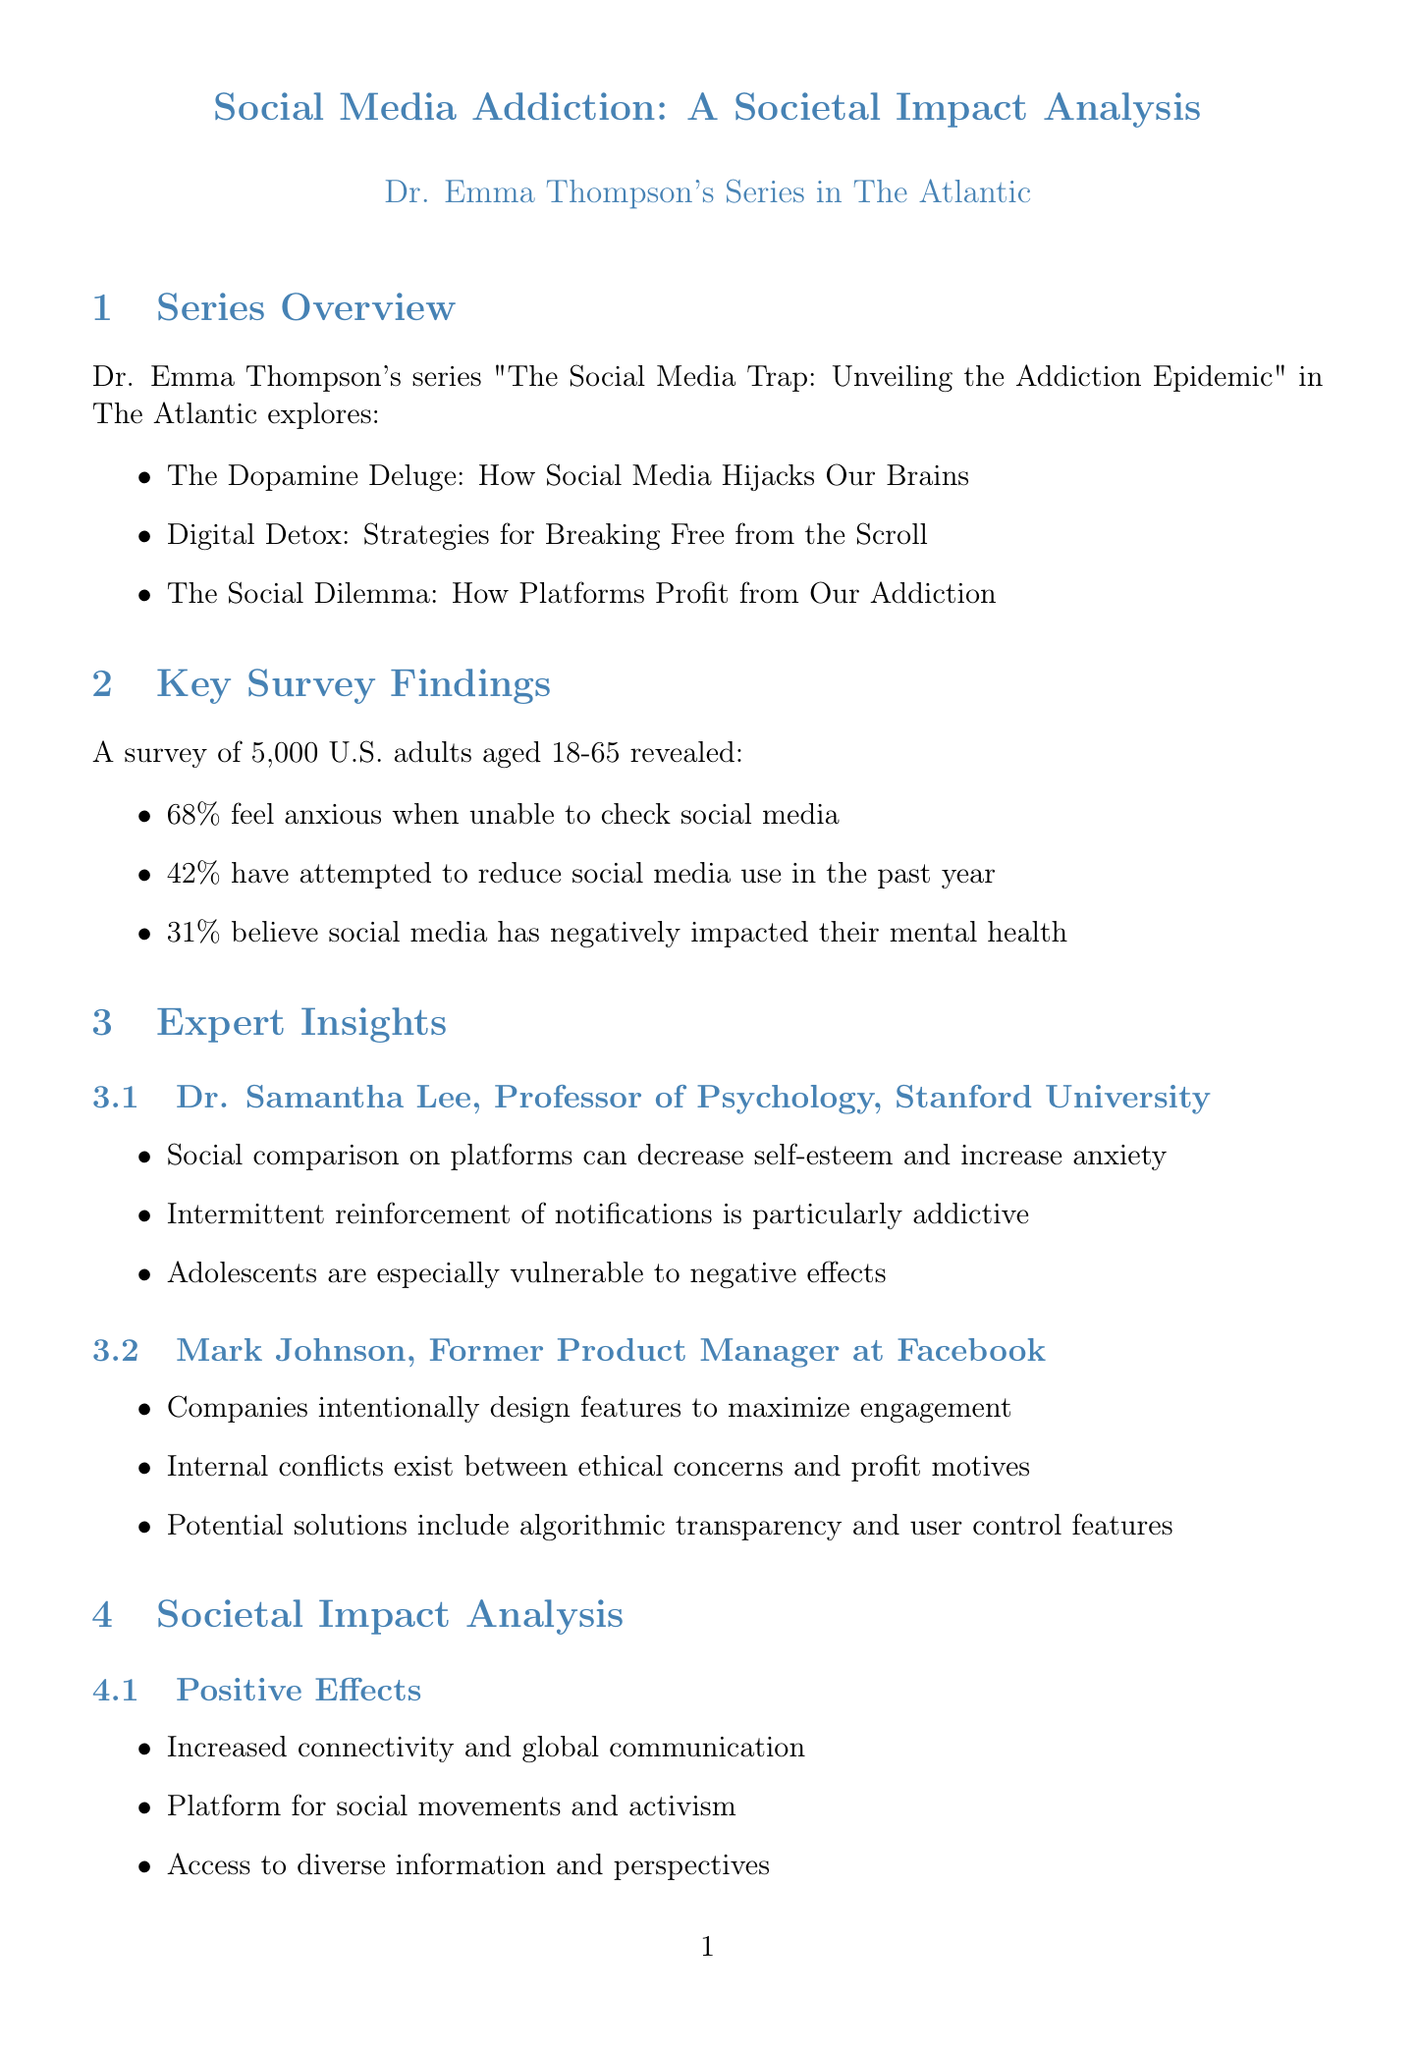What is the name of the columnist? The document mentions Dr. Emma Thompson as the columnist.
Answer: Dr. Emma Thompson What is the title of the series? The title of the series is provided in the document as "The Social Media Trap: Unveiling the Addiction Epidemic."
Answer: The Social Media Trap: Unveiling the Addiction Epidemic How many adults participated in the survey? The document states that the survey included 5,000 U.S. adults aged 18-65.
Answer: 5000 What percentage of respondents feels anxious without checking social media? The survey results indicate that 68% of respondents report anxiety when not checking social media.
Answer: 68% Who is the expert from Stanford University? The document lists Dr. Samantha Lee as the expert from Stanford University.
Answer: Dr. Samantha Lee What is one of the positive effects of social media mentioned? A positive effect listed in the document is increased connectivity and global communication.
Answer: Increased connectivity and global communication Which company did Mark Johnson formerly work for? The document indicates that Mark Johnson was a former product manager at Facebook.
Answer: Facebook What is one recommendation for future research? The document includes a recommendation for longitudinal studies on the developmental impacts of social media use.
Answer: Longitudinal studies on developmental impacts of social media use What is the implication of 31% of respondents believing social media has negatively affected their mental health? The document states that this indicates a significant perceived psychological toll of excessive use.
Answer: Significant perceived psychological toll of excessive use 